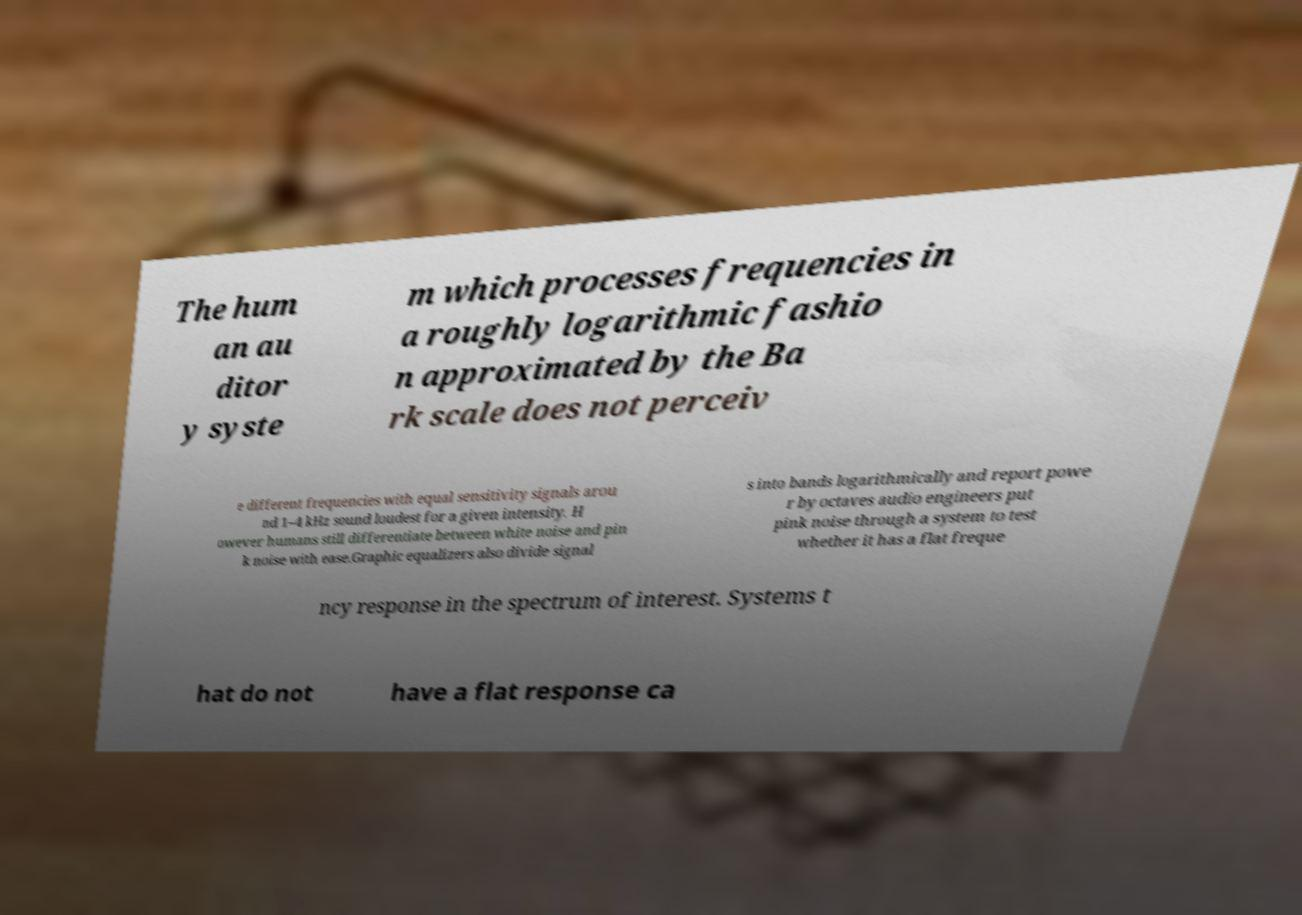I need the written content from this picture converted into text. Can you do that? The hum an au ditor y syste m which processes frequencies in a roughly logarithmic fashio n approximated by the Ba rk scale does not perceiv e different frequencies with equal sensitivity signals arou nd 1–4 kHz sound loudest for a given intensity. H owever humans still differentiate between white noise and pin k noise with ease.Graphic equalizers also divide signal s into bands logarithmically and report powe r by octaves audio engineers put pink noise through a system to test whether it has a flat freque ncy response in the spectrum of interest. Systems t hat do not have a flat response ca 